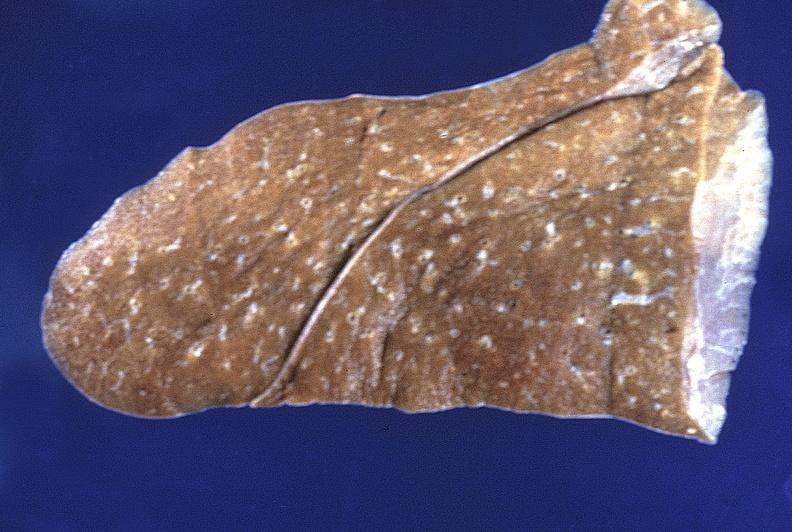what does this image show?
Answer the question using a single word or phrase. Normal lung 